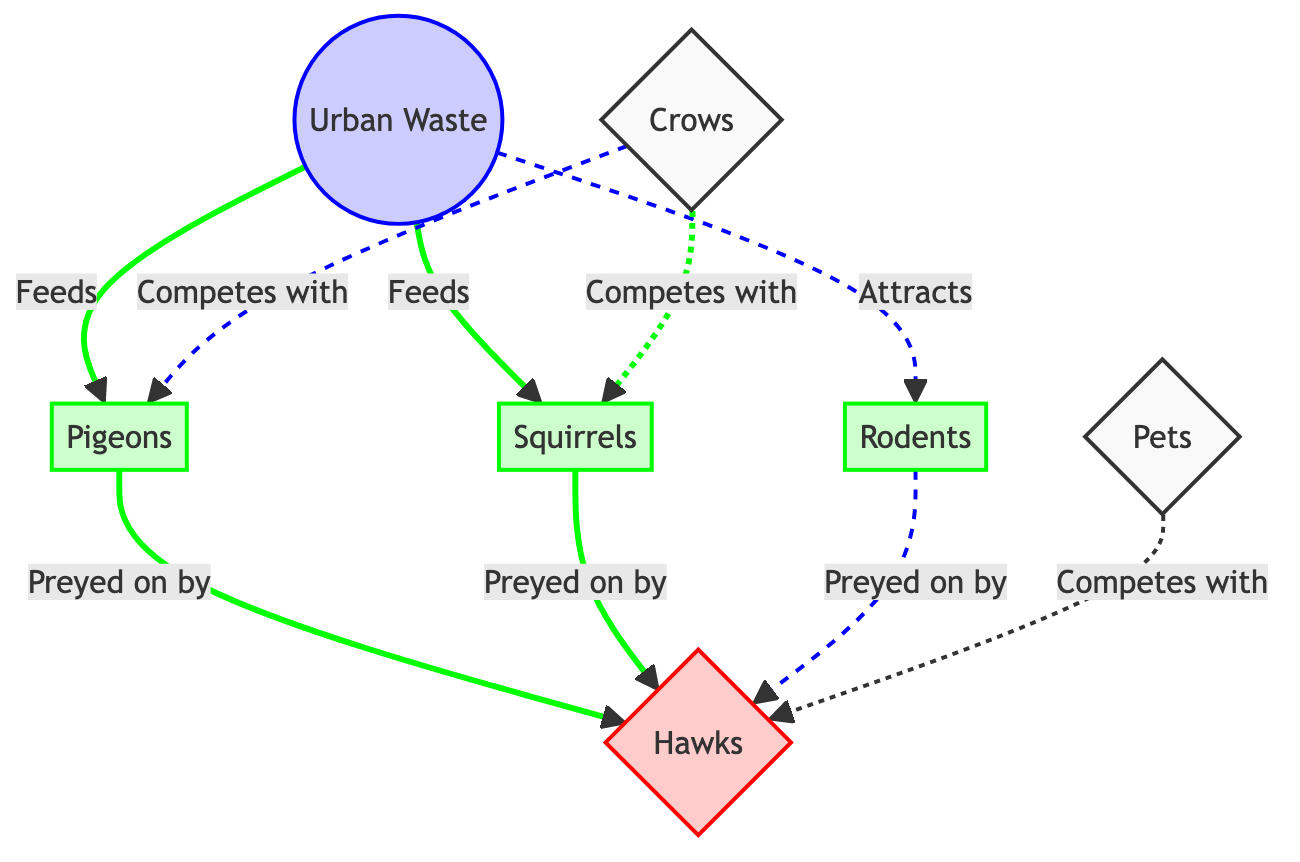What is at the top of the food chain in this diagram? The diagram indicates that the top of the food chain consists of the hawks, which are represented as a predator. They are positioned to show they prey on various animals, making them the highest level in this urban food chain.
Answer: Hawks How many prey animals are there in the diagram? The diagram lists three different prey animals: pigeons, squirrels, and rodents. By counting these nodes specifically labeled as prey, we find that there are three distinct prey animals.
Answer: Three What does urban waste feed? The diagram shows that urban waste feeds both pigeons and squirrels, indicating a relationship where these prey animals derive sustenance from waste in the urban environment.
Answer: Pigeons and squirrels Which animal competes with pigeons? The diagram indicates that crows compete with pigeons. This competitive relationship shows an interaction between these two species in the urban wildlife context.
Answer: Crows How many predator animals are shown in the diagram? The diagram includes only one predator type: hawks. Since there are no other labels indicating predators, the total count of predator animals is one.
Answer: One Which organisms attract rodents? Urban waste is shown to attract rodents, as indicated by a dashed line that connects these two entities, representing that the presence of waste in urban areas brings rodents into those environments.
Answer: Urban Waste Which two prey animals can be preyed upon by hawks? Both pigeons and squirrels are indicated to be preyed upon by hawks in the diagram, showing that these two prey species are part of the hawks' diet in the urban food chain.
Answer: Pigeons and squirrels What type of competition is indicated in the diagram? The diagram labels competition using dashed lines, specifically pointing out the competition between crows with pigeons and squirrels. This indicates a non-predatory interaction where food resources are contested.
Answer: Competition What draws in the populations of rodents in urban areas? Urban waste is depicted as the factor that attracts rodents, illustrating how waste can increase rodent populations in cities, thereby altering the dynamics of the food chain.
Answer: Urban Waste 